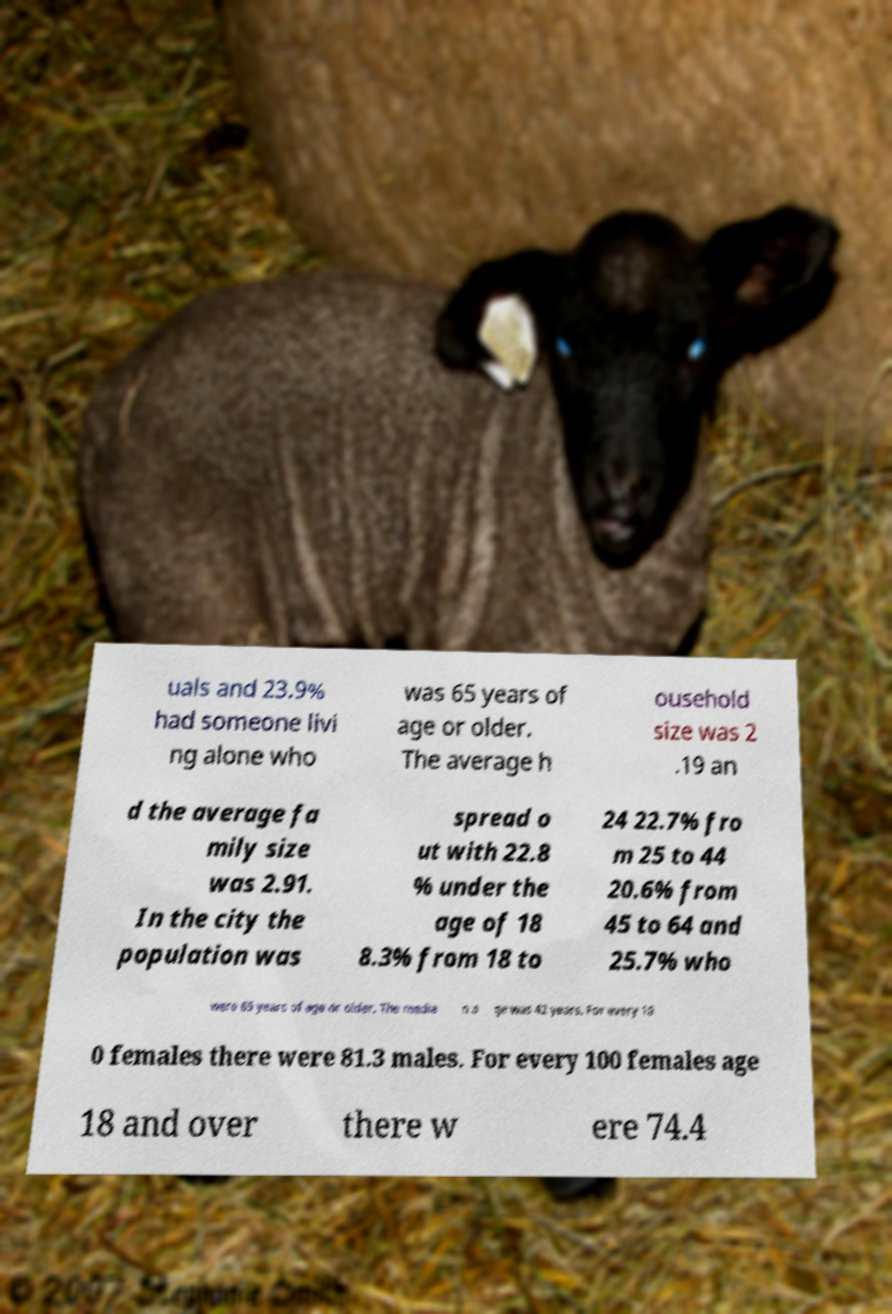Could you extract and type out the text from this image? uals and 23.9% had someone livi ng alone who was 65 years of age or older. The average h ousehold size was 2 .19 an d the average fa mily size was 2.91. In the city the population was spread o ut with 22.8 % under the age of 18 8.3% from 18 to 24 22.7% fro m 25 to 44 20.6% from 45 to 64 and 25.7% who were 65 years of age or older. The media n a ge was 42 years. For every 10 0 females there were 81.3 males. For every 100 females age 18 and over there w ere 74.4 